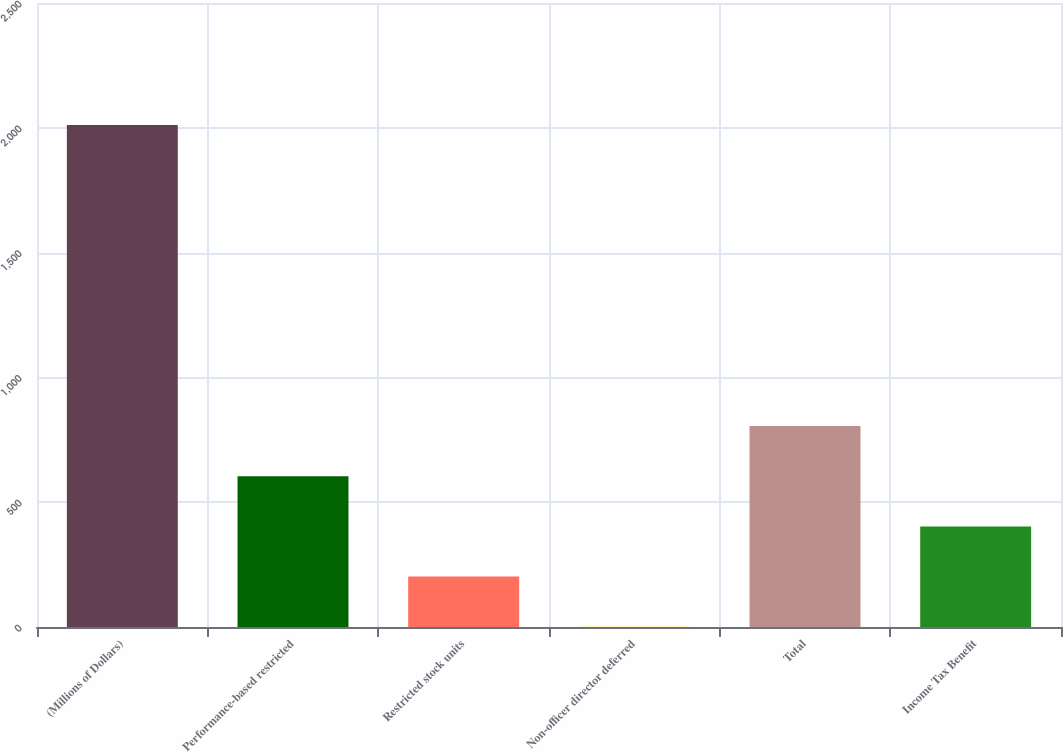<chart> <loc_0><loc_0><loc_500><loc_500><bar_chart><fcel>(Millions of Dollars)<fcel>Performance-based restricted<fcel>Restricted stock units<fcel>Non-officer director deferred<fcel>Total<fcel>Income Tax Benefit<nl><fcel>2011<fcel>604<fcel>202<fcel>1<fcel>805<fcel>403<nl></chart> 